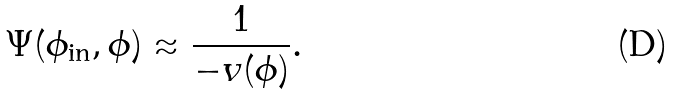Convert formula to latex. <formula><loc_0><loc_0><loc_500><loc_500>\Psi ( \phi _ { \text {in} } , \phi ) \approx \frac { 1 } { - v ( \phi ) } .</formula> 